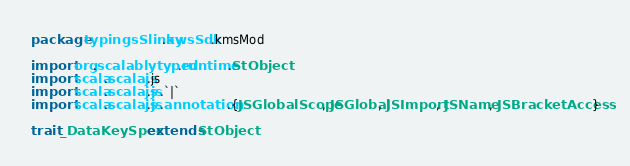<code> <loc_0><loc_0><loc_500><loc_500><_Scala_>package typingsSlinky.awsSdk.kmsMod

import org.scalablytyped.runtime.StObject
import scala.scalajs.js
import scala.scalajs.js.`|`
import scala.scalajs.js.annotation.{JSGlobalScope, JSGlobal, JSImport, JSName, JSBracketAccess}

trait _DataKeySpec extends StObject
</code> 